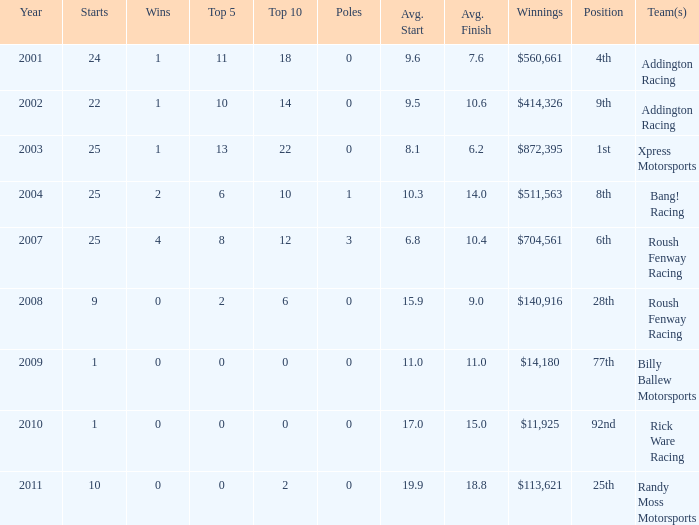What's the count of wins at the 4th position? 1.0. 